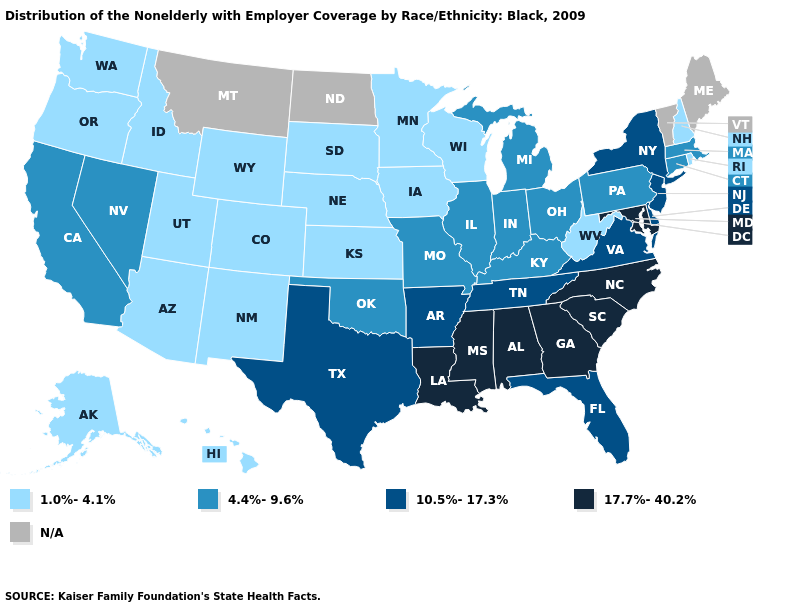What is the value of Oregon?
Quick response, please. 1.0%-4.1%. Which states have the lowest value in the West?
Be succinct. Alaska, Arizona, Colorado, Hawaii, Idaho, New Mexico, Oregon, Utah, Washington, Wyoming. Name the states that have a value in the range 1.0%-4.1%?
Concise answer only. Alaska, Arizona, Colorado, Hawaii, Idaho, Iowa, Kansas, Minnesota, Nebraska, New Hampshire, New Mexico, Oregon, Rhode Island, South Dakota, Utah, Washington, West Virginia, Wisconsin, Wyoming. Name the states that have a value in the range 1.0%-4.1%?
Short answer required. Alaska, Arizona, Colorado, Hawaii, Idaho, Iowa, Kansas, Minnesota, Nebraska, New Hampshire, New Mexico, Oregon, Rhode Island, South Dakota, Utah, Washington, West Virginia, Wisconsin, Wyoming. Among the states that border Tennessee , which have the highest value?
Write a very short answer. Alabama, Georgia, Mississippi, North Carolina. Does Delaware have the lowest value in the USA?
Keep it brief. No. Among the states that border Vermont , which have the highest value?
Keep it brief. New York. Name the states that have a value in the range 4.4%-9.6%?
Give a very brief answer. California, Connecticut, Illinois, Indiana, Kentucky, Massachusetts, Michigan, Missouri, Nevada, Ohio, Oklahoma, Pennsylvania. Is the legend a continuous bar?
Concise answer only. No. What is the lowest value in states that border Maryland?
Be succinct. 1.0%-4.1%. Name the states that have a value in the range 17.7%-40.2%?
Concise answer only. Alabama, Georgia, Louisiana, Maryland, Mississippi, North Carolina, South Carolina. Name the states that have a value in the range N/A?
Be succinct. Maine, Montana, North Dakota, Vermont. Which states hav the highest value in the South?
Write a very short answer. Alabama, Georgia, Louisiana, Maryland, Mississippi, North Carolina, South Carolina. Does Idaho have the lowest value in the West?
Quick response, please. Yes. Which states have the lowest value in the South?
Give a very brief answer. West Virginia. 